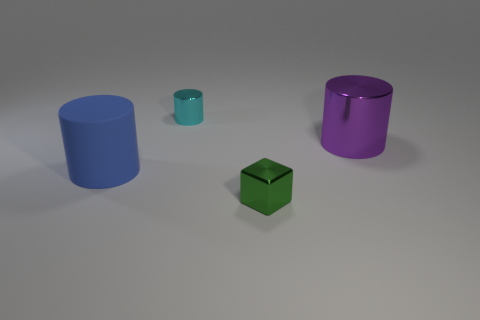Subtract all cyan cylinders. How many cylinders are left? 2 Add 1 large cylinders. How many objects exist? 5 Subtract all cylinders. How many objects are left? 1 Add 1 small purple shiny balls. How many small purple shiny balls exist? 1 Subtract 0 brown cylinders. How many objects are left? 4 Subtract all blue matte cylinders. Subtract all big purple rubber objects. How many objects are left? 3 Add 1 tiny green things. How many tiny green things are left? 2 